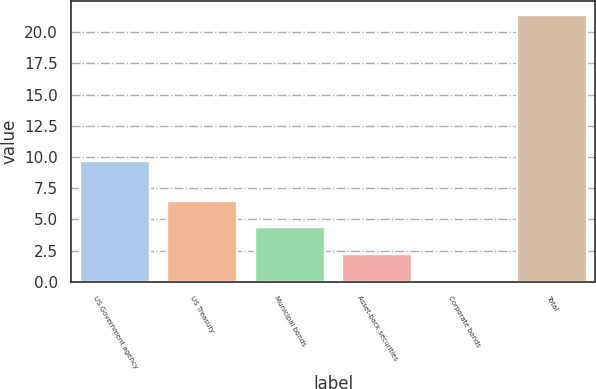Convert chart to OTSL. <chart><loc_0><loc_0><loc_500><loc_500><bar_chart><fcel>US Government agency<fcel>US Treasury<fcel>Municipal bonds<fcel>Asset-back securities<fcel>Corporate bonds<fcel>Total<nl><fcel>9.7<fcel>6.49<fcel>4.36<fcel>2.23<fcel>0.1<fcel>21.4<nl></chart> 